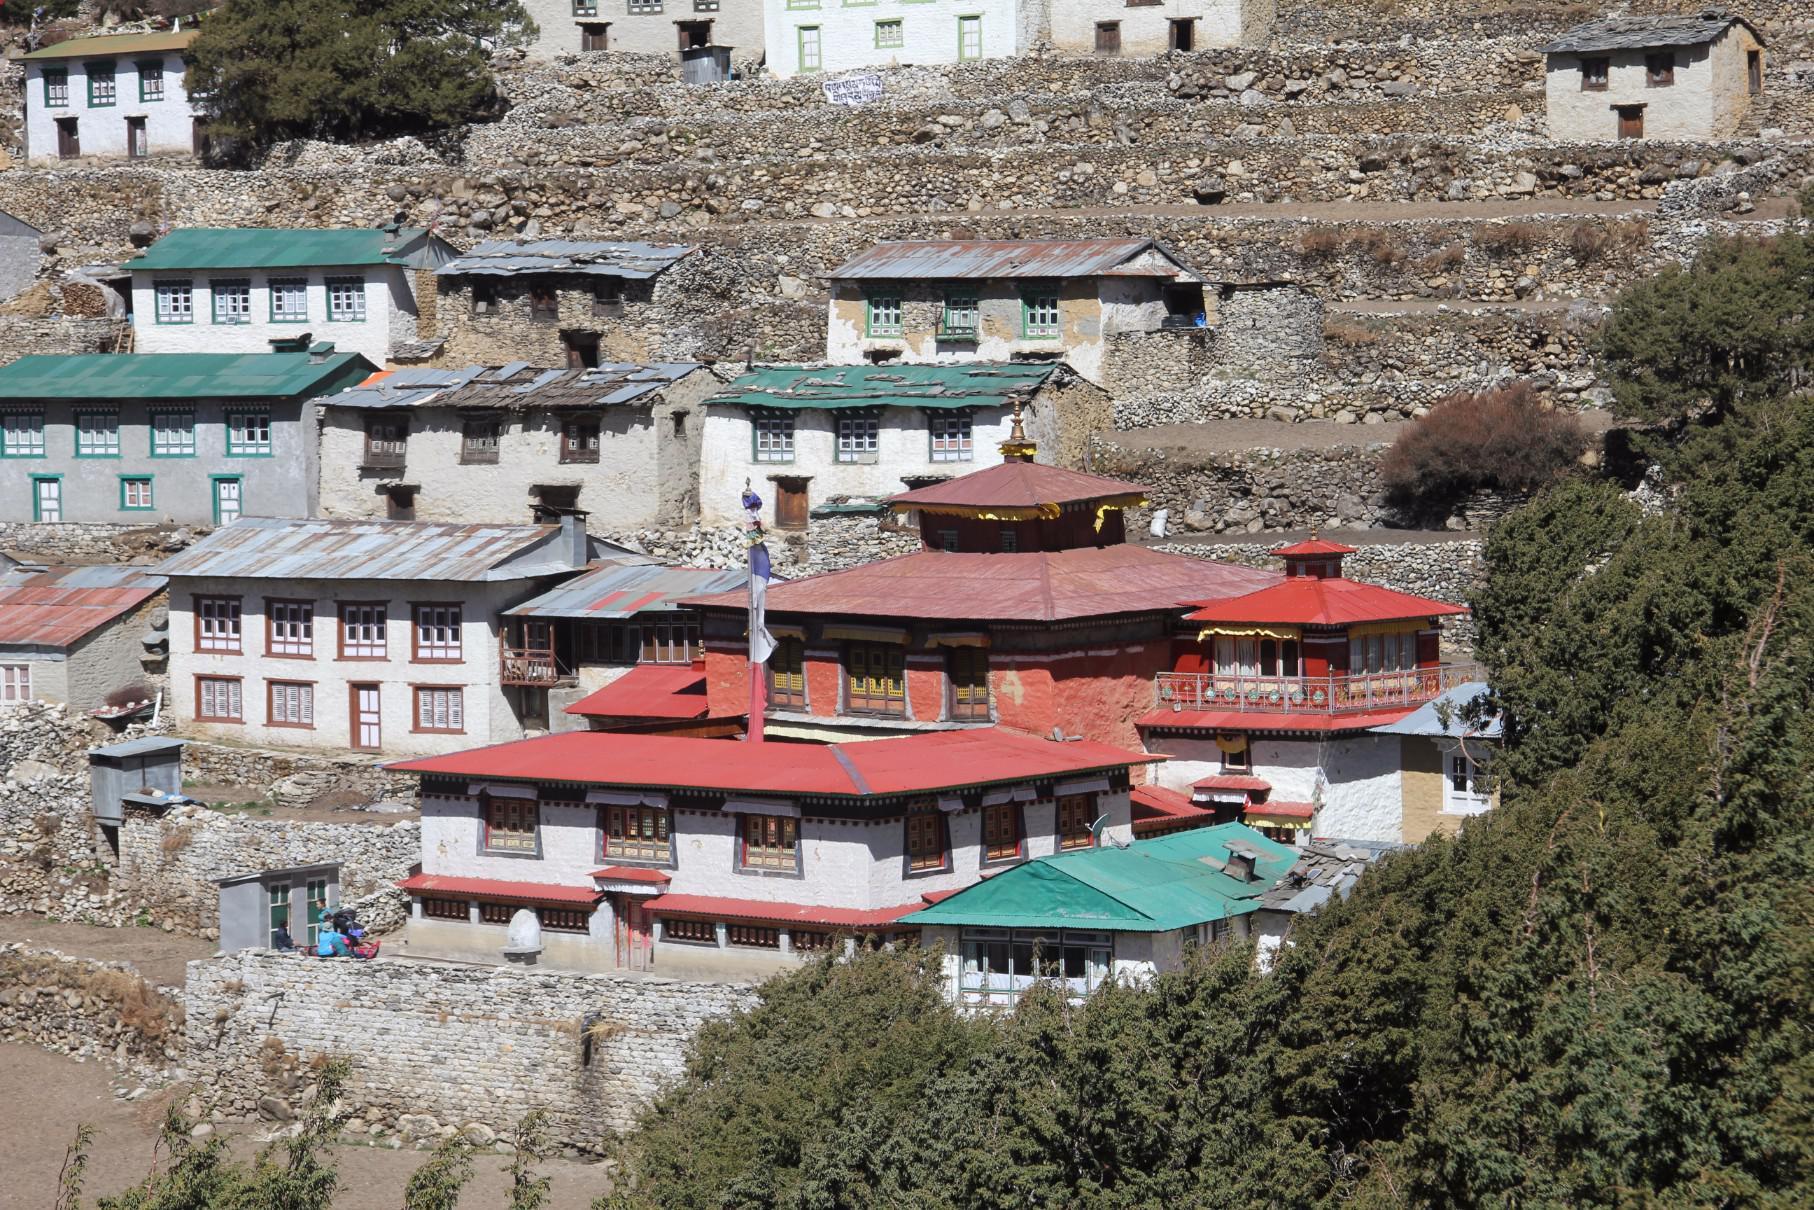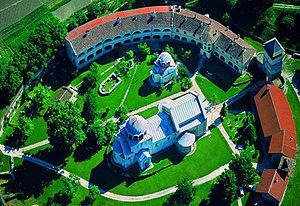The first image is the image on the left, the second image is the image on the right. For the images displayed, is the sentence "Some roofs are green." factually correct? Answer yes or no. Yes. The first image is the image on the left, the second image is the image on the right. For the images shown, is this caption "In at least one image there is at least ten white house under a yellow house." true? Answer yes or no. No. 